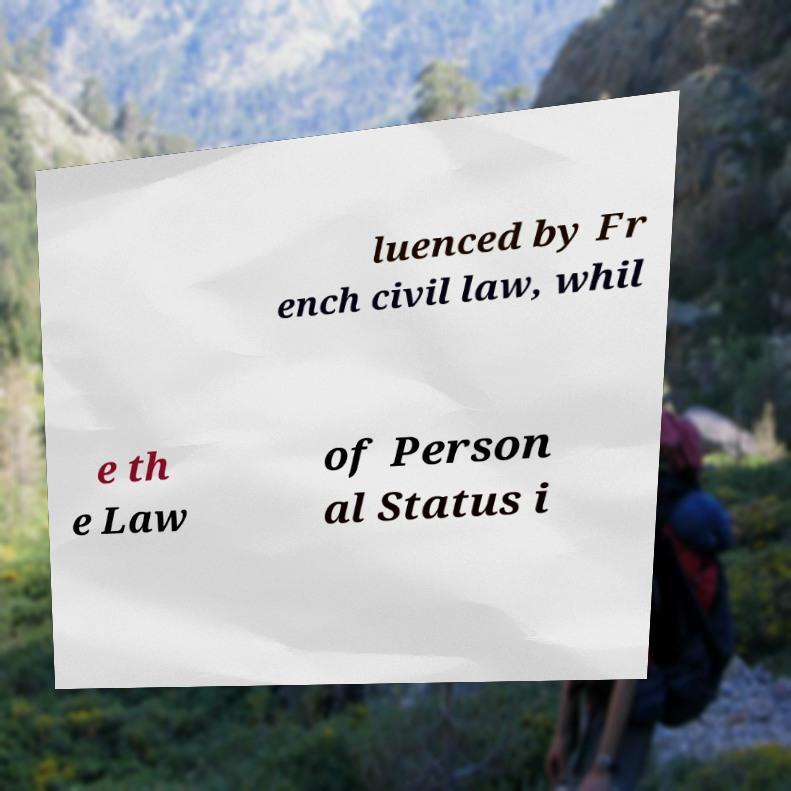Can you read and provide the text displayed in the image?This photo seems to have some interesting text. Can you extract and type it out for me? luenced by Fr ench civil law, whil e th e Law of Person al Status i 